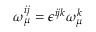<formula> <loc_0><loc_0><loc_500><loc_500>\omega _ { \mu } ^ { i j } = \epsilon ^ { i j k } \omega _ { \mu } ^ { k }</formula> 